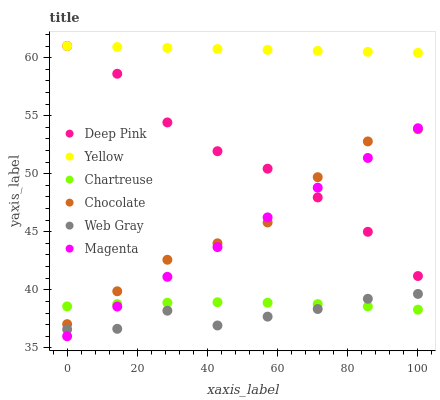Does Web Gray have the minimum area under the curve?
Answer yes or no. Yes. Does Yellow have the maximum area under the curve?
Answer yes or no. Yes. Does Chocolate have the minimum area under the curve?
Answer yes or no. No. Does Chocolate have the maximum area under the curve?
Answer yes or no. No. Is Yellow the smoothest?
Answer yes or no. Yes. Is Web Gray the roughest?
Answer yes or no. Yes. Is Chocolate the smoothest?
Answer yes or no. No. Is Chocolate the roughest?
Answer yes or no. No. Does Magenta have the lowest value?
Answer yes or no. Yes. Does Chocolate have the lowest value?
Answer yes or no. No. Does Yellow have the highest value?
Answer yes or no. Yes. Does Chocolate have the highest value?
Answer yes or no. No. Is Chartreuse less than Deep Pink?
Answer yes or no. Yes. Is Yellow greater than Web Gray?
Answer yes or no. Yes. Does Magenta intersect Chartreuse?
Answer yes or no. Yes. Is Magenta less than Chartreuse?
Answer yes or no. No. Is Magenta greater than Chartreuse?
Answer yes or no. No. Does Chartreuse intersect Deep Pink?
Answer yes or no. No. 